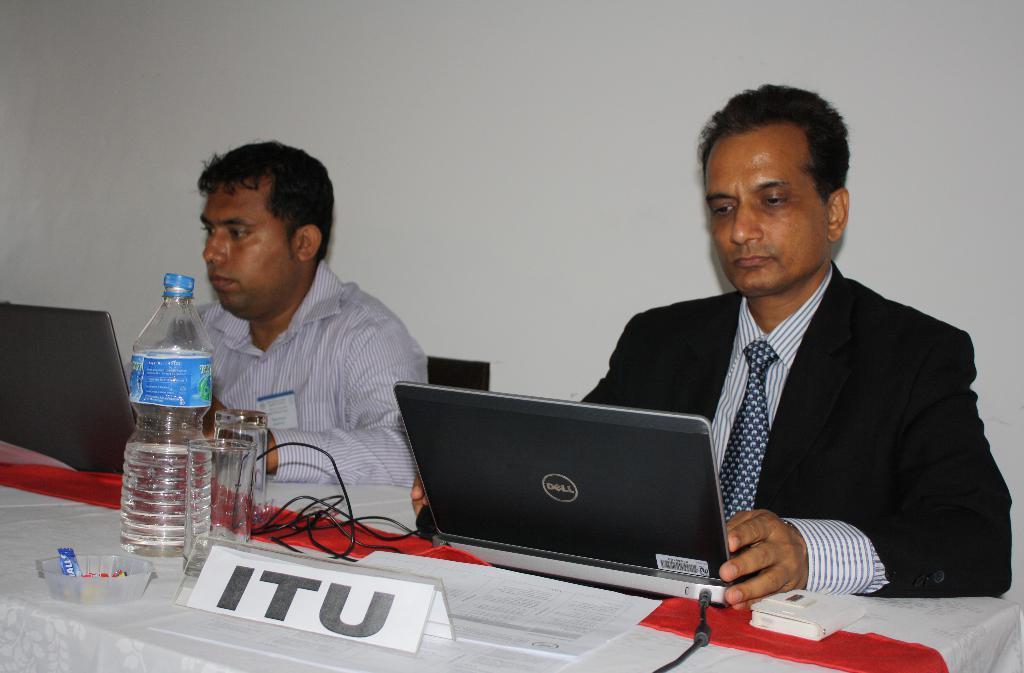In one or two sentences, can you explain what this image depicts? In the center of the image there are two people sitting before them there is a table. On the table there is a bottle, glasses, laptops, bowl and some papers. In the background there is a wall. 